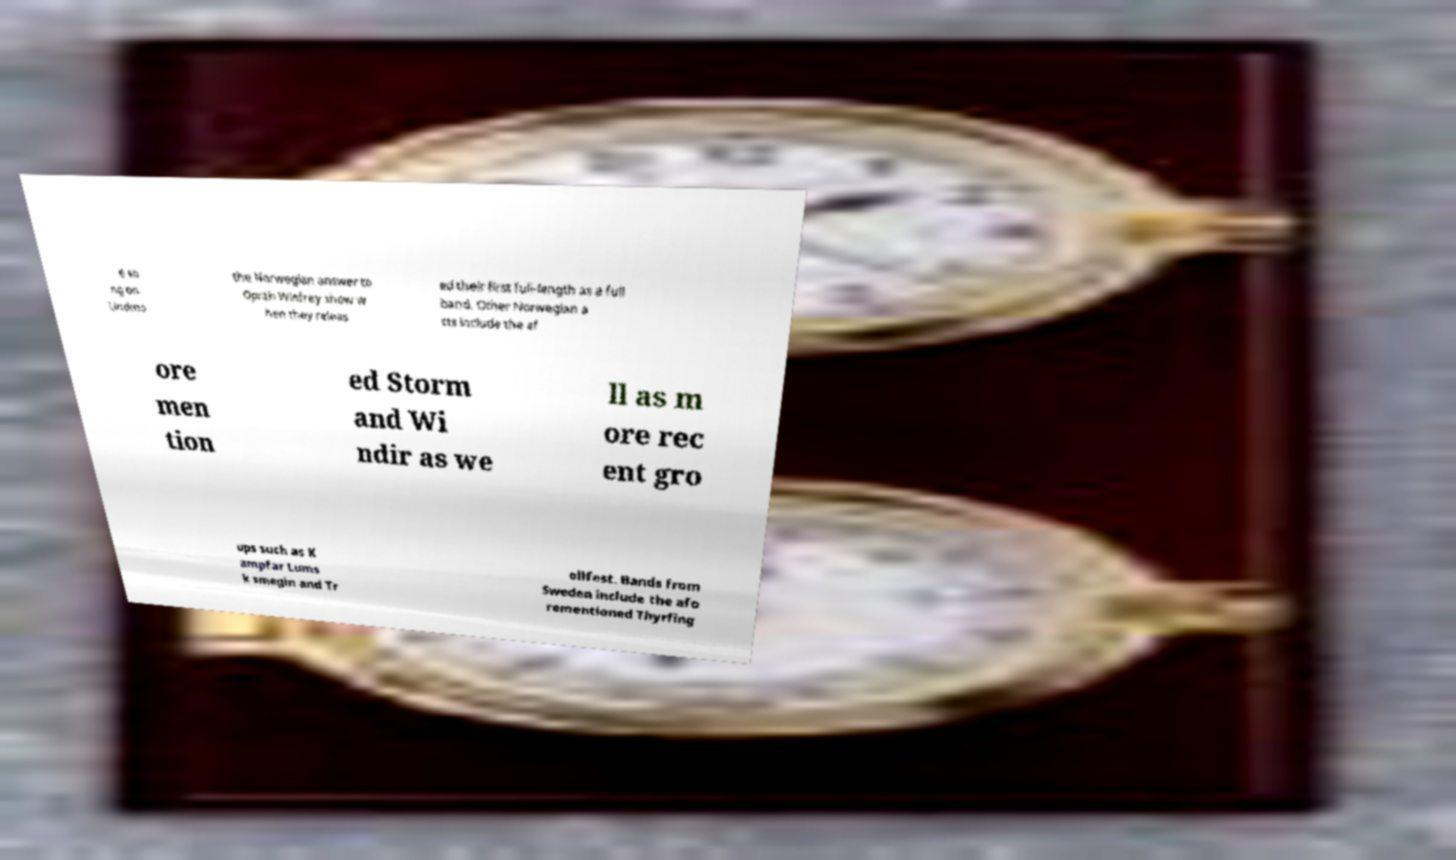Can you accurately transcribe the text from the provided image for me? e so ng on Lindmo the Norwegian answer to Oprah Winfrey show w hen they releas ed their first full-length as a full band. Other Norwegian a cts include the af ore men tion ed Storm and Wi ndir as we ll as m ore rec ent gro ups such as K ampfar Lums k smegin and Tr ollfest. Bands from Sweden include the afo rementioned Thyrfing 